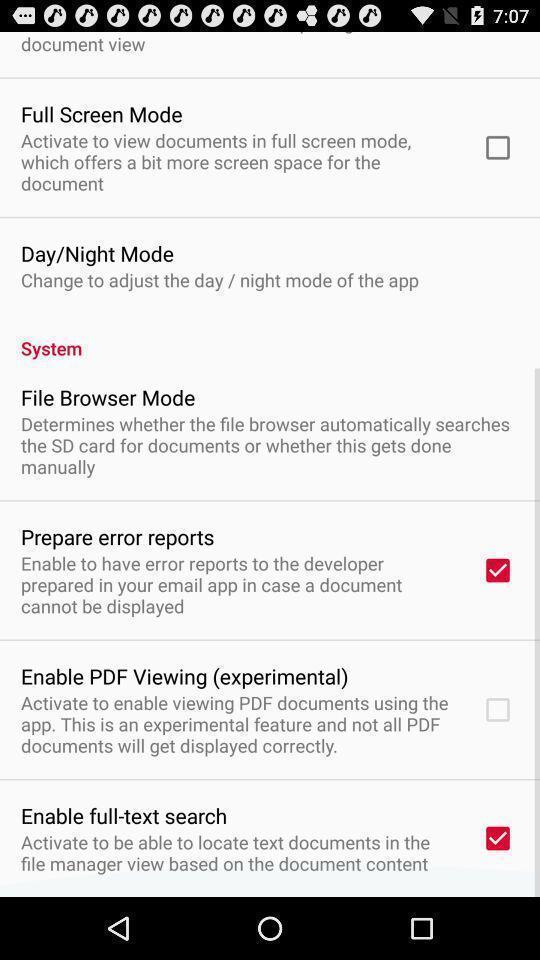Describe the key features of this screenshot. Screen shows different settings on an app. 